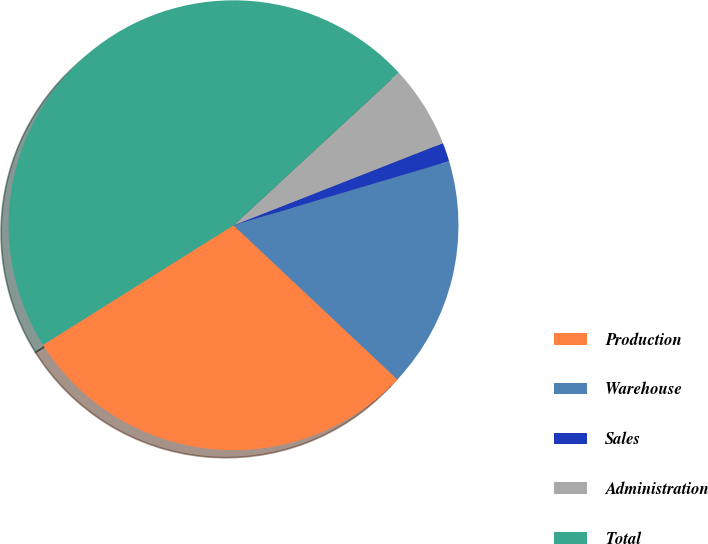Convert chart. <chart><loc_0><loc_0><loc_500><loc_500><pie_chart><fcel>Production<fcel>Warehouse<fcel>Sales<fcel>Administration<fcel>Total<nl><fcel>29.06%<fcel>16.61%<fcel>1.36%<fcel>5.92%<fcel>47.05%<nl></chart> 